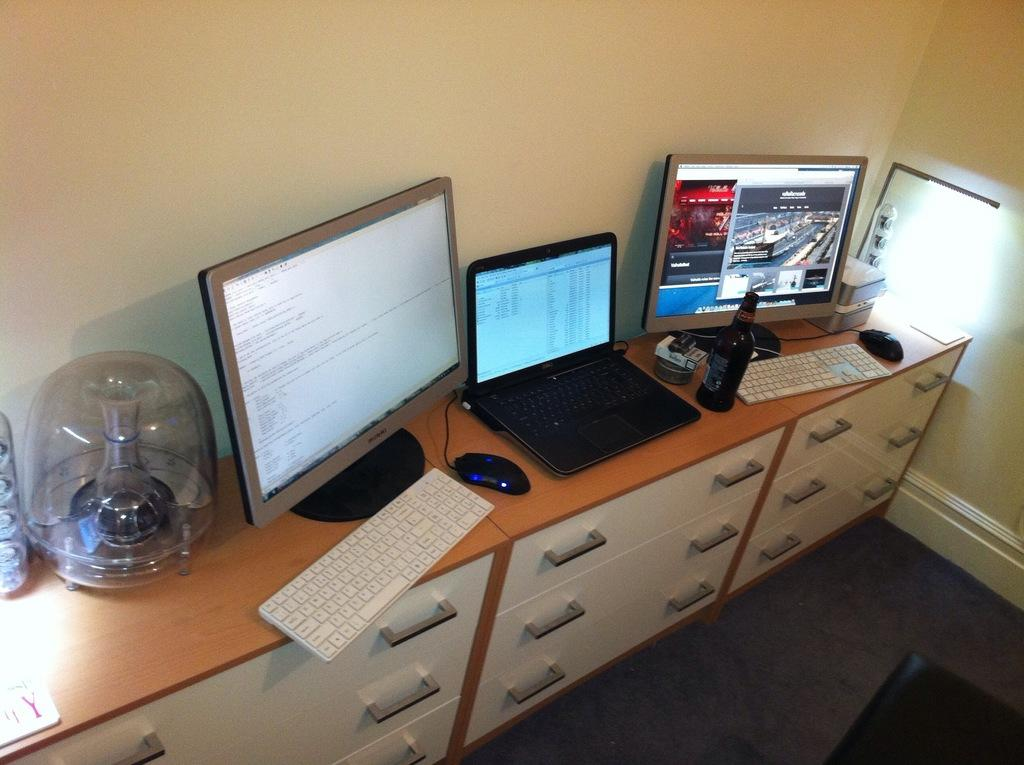What piece of furniture is present in the image? There is a table in the image. What electronic device is on the table? There is a keyboard, a mouse, a laptop, and a monitor on the table. What type of container is on the table? There is a bottle on the table. What storage feature is present under the table? There are racks under the table. What type of garden can be seen growing in the image? There is no garden present in the image; it features a table with electronic devices and other items. Can you tell me how many corn plants are visible in the image? There are no corn plants present in the image. 